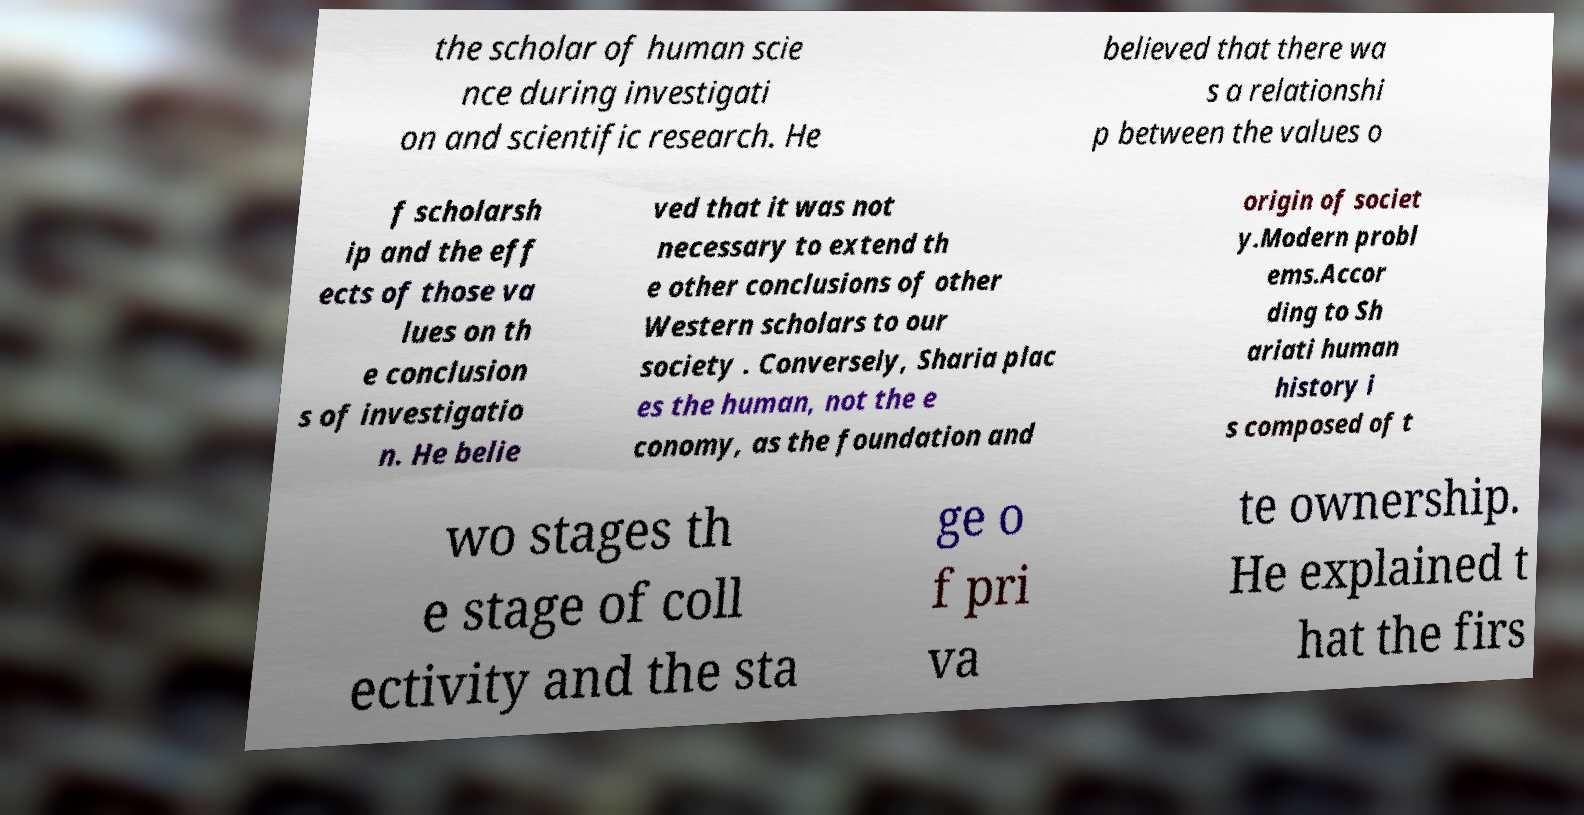There's text embedded in this image that I need extracted. Can you transcribe it verbatim? the scholar of human scie nce during investigati on and scientific research. He believed that there wa s a relationshi p between the values o f scholarsh ip and the eff ects of those va lues on th e conclusion s of investigatio n. He belie ved that it was not necessary to extend th e other conclusions of other Western scholars to our society . Conversely, Sharia plac es the human, not the e conomy, as the foundation and origin of societ y.Modern probl ems.Accor ding to Sh ariati human history i s composed of t wo stages th e stage of coll ectivity and the sta ge o f pri va te ownership. He explained t hat the firs 